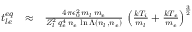Convert formula to latex. <formula><loc_0><loc_0><loc_500><loc_500>\begin{array} { r l r } { t _ { l e } ^ { e q } } & { \approx } & { \frac { 4 \pi \epsilon _ { 0 } ^ { 2 } \, m _ { l } \, m _ { e } } { Z _ { l } ^ { 2 } \, q _ { e } ^ { 4 } \, n _ { e } \, \ln \Lambda \left ( n _ { l } , n _ { e } \right ) } \, \left ( \frac { k T _ { i } } { m _ { l } } + \frac { k T _ { e } } { m _ { e } } \right ) ^ { \frac { 3 } { 2 } } } \end{array}</formula> 